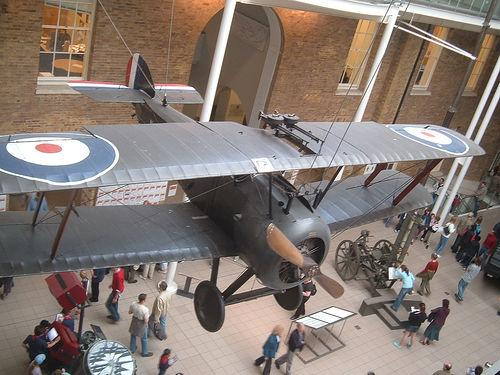What does this building house? planes 